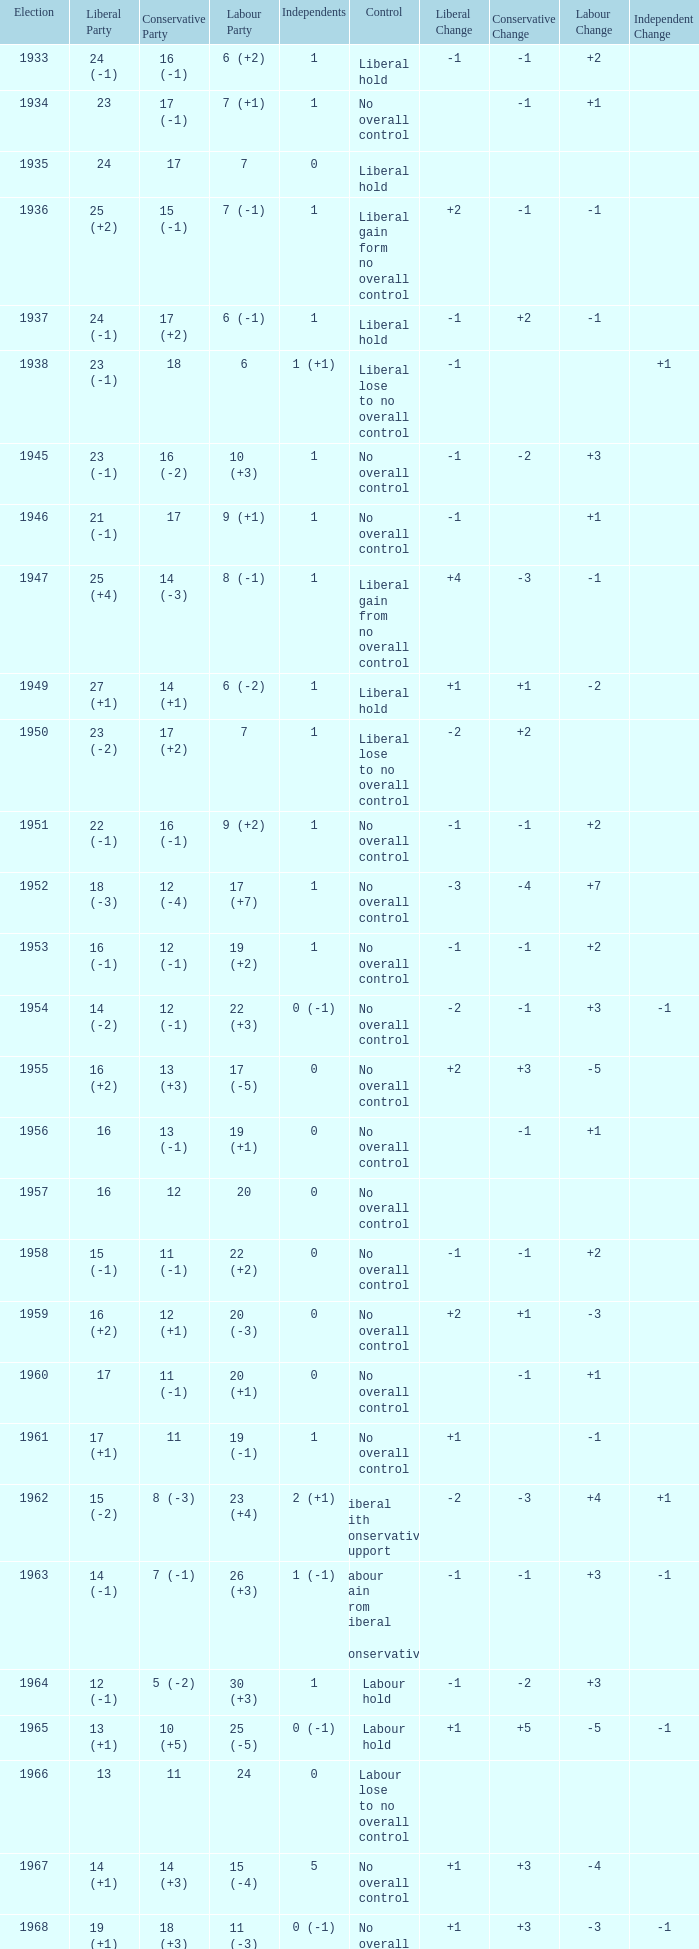What was the control for the year with a Conservative Party result of 10 (+5)? Labour hold. 